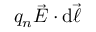Convert formula to latex. <formula><loc_0><loc_0><loc_500><loc_500>q _ { n } { \vec { E } } \cdot d { \vec { \ell } }</formula> 